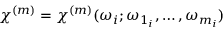<formula> <loc_0><loc_0><loc_500><loc_500>\chi ^ { ( m ) } = \chi ^ { ( m ) } ( \omega _ { i } ; \omega _ { 1 _ { i } } , \dots , \omega _ { m _ { i } } )</formula> 